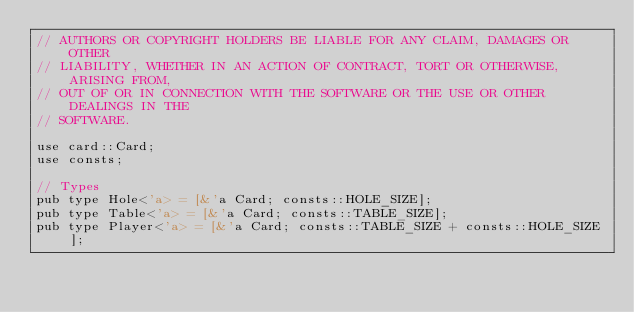<code> <loc_0><loc_0><loc_500><loc_500><_Rust_>// AUTHORS OR COPYRIGHT HOLDERS BE LIABLE FOR ANY CLAIM, DAMAGES OR OTHER
// LIABILITY, WHETHER IN AN ACTION OF CONTRACT, TORT OR OTHERWISE, ARISING FROM,
// OUT OF OR IN CONNECTION WITH THE SOFTWARE OR THE USE OR OTHER DEALINGS IN THE
// SOFTWARE.

use card::Card;
use consts;

// Types
pub type Hole<'a> = [&'a Card; consts::HOLE_SIZE];
pub type Table<'a> = [&'a Card; consts::TABLE_SIZE];
pub type Player<'a> = [&'a Card; consts::TABLE_SIZE + consts::HOLE_SIZE];
</code> 